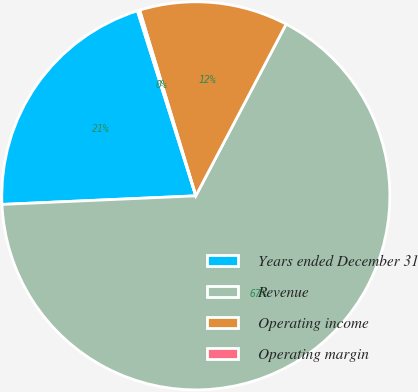<chart> <loc_0><loc_0><loc_500><loc_500><pie_chart><fcel>Years ended December 31<fcel>Revenue<fcel>Operating income<fcel>Operating margin<nl><fcel>20.84%<fcel>66.59%<fcel>12.38%<fcel>0.19%<nl></chart> 